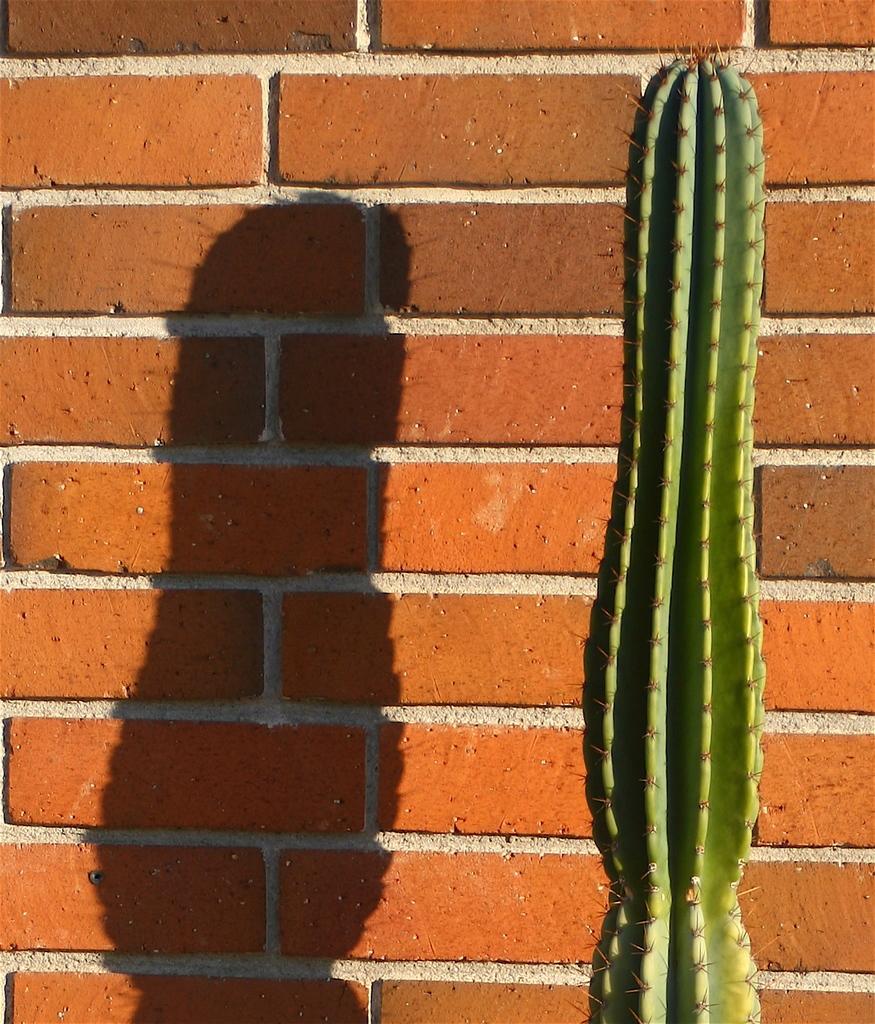In one or two sentences, can you explain what this image depicts? In the picture I can see the cactus plant on the right side. In the background, I can see the brick wall and there is a shadow of the plant on the wall. 